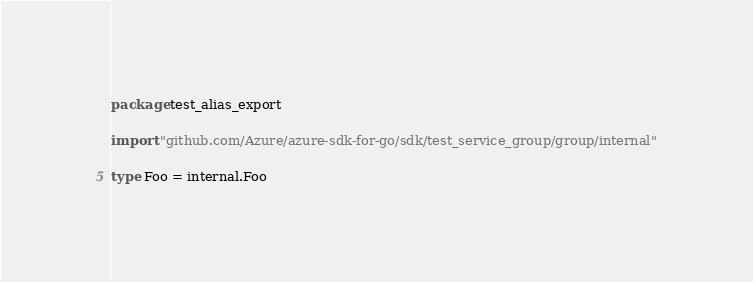Convert code to text. <code><loc_0><loc_0><loc_500><loc_500><_Go_>package test_alias_export

import "github.com/Azure/azure-sdk-for-go/sdk/test_service_group/group/internal"

type Foo = internal.Foo
</code> 